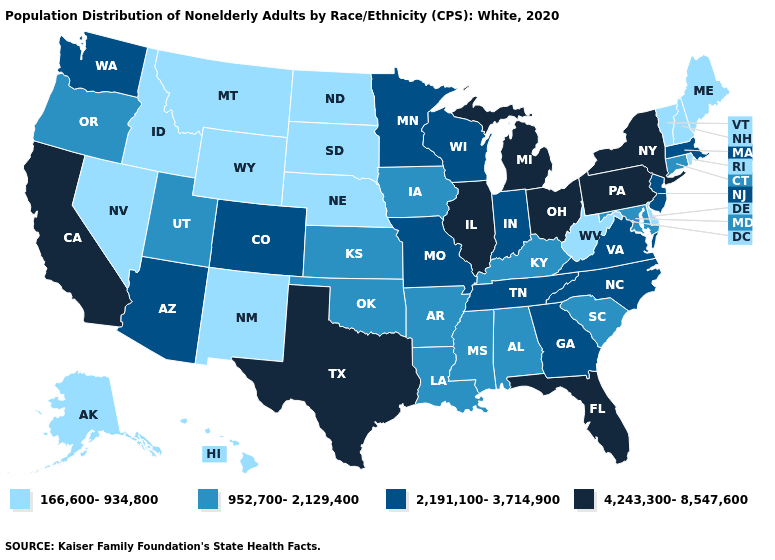What is the lowest value in the USA?
Be succinct. 166,600-934,800. What is the value of Nebraska?
Concise answer only. 166,600-934,800. Among the states that border West Virginia , which have the highest value?
Short answer required. Ohio, Pennsylvania. Which states have the highest value in the USA?
Write a very short answer. California, Florida, Illinois, Michigan, New York, Ohio, Pennsylvania, Texas. Does California have the highest value in the USA?
Give a very brief answer. Yes. What is the highest value in the Northeast ?
Concise answer only. 4,243,300-8,547,600. Among the states that border Missouri , does Kentucky have the lowest value?
Concise answer only. No. What is the value of Hawaii?
Write a very short answer. 166,600-934,800. Among the states that border Virginia , does North Carolina have the highest value?
Quick response, please. Yes. What is the value of Florida?
Concise answer only. 4,243,300-8,547,600. What is the value of Washington?
Keep it brief. 2,191,100-3,714,900. Does the map have missing data?
Concise answer only. No. What is the value of South Dakota?
Short answer required. 166,600-934,800. Does Arizona have the highest value in the West?
Short answer required. No. What is the lowest value in the USA?
Give a very brief answer. 166,600-934,800. 